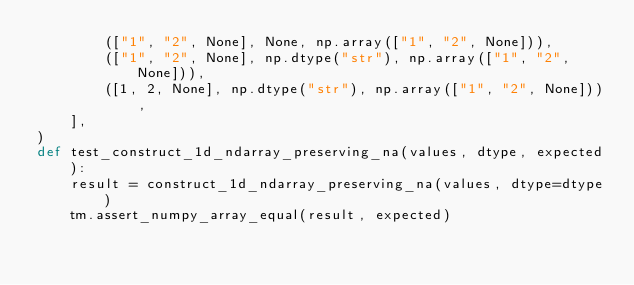Convert code to text. <code><loc_0><loc_0><loc_500><loc_500><_Python_>        (["1", "2", None], None, np.array(["1", "2", None])),
        (["1", "2", None], np.dtype("str"), np.array(["1", "2", None])),
        ([1, 2, None], np.dtype("str"), np.array(["1", "2", None])),
    ],
)
def test_construct_1d_ndarray_preserving_na(values, dtype, expected):
    result = construct_1d_ndarray_preserving_na(values, dtype=dtype)
    tm.assert_numpy_array_equal(result, expected)
</code> 